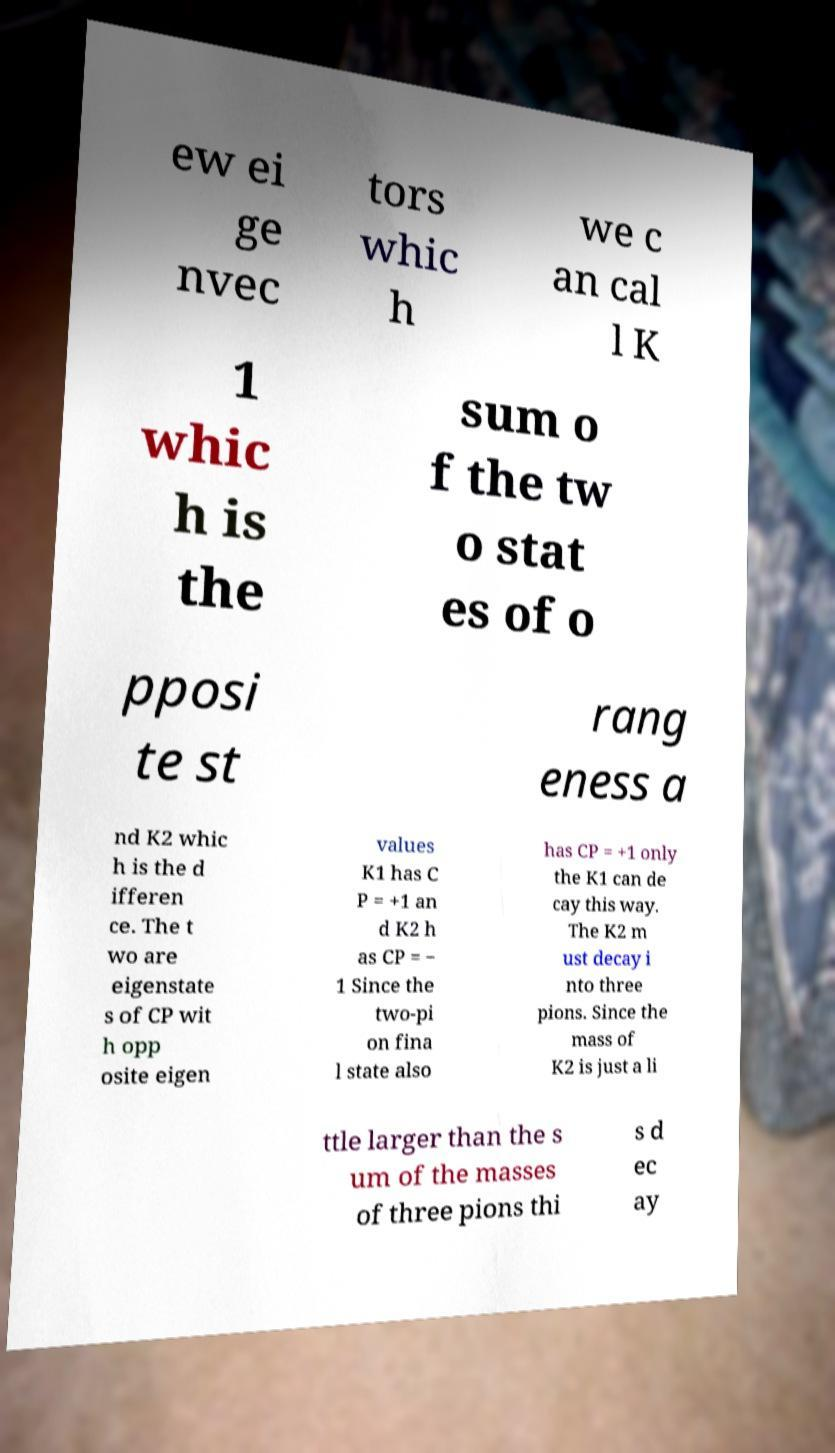Can you read and provide the text displayed in the image?This photo seems to have some interesting text. Can you extract and type it out for me? ew ei ge nvec tors whic h we c an cal l K 1 whic h is the sum o f the tw o stat es of o pposi te st rang eness a nd K2 whic h is the d ifferen ce. The t wo are eigenstate s of CP wit h opp osite eigen values K1 has C P = +1 an d K2 h as CP = − 1 Since the two-pi on fina l state also has CP = +1 only the K1 can de cay this way. The K2 m ust decay i nto three pions. Since the mass of K2 is just a li ttle larger than the s um of the masses of three pions thi s d ec ay 